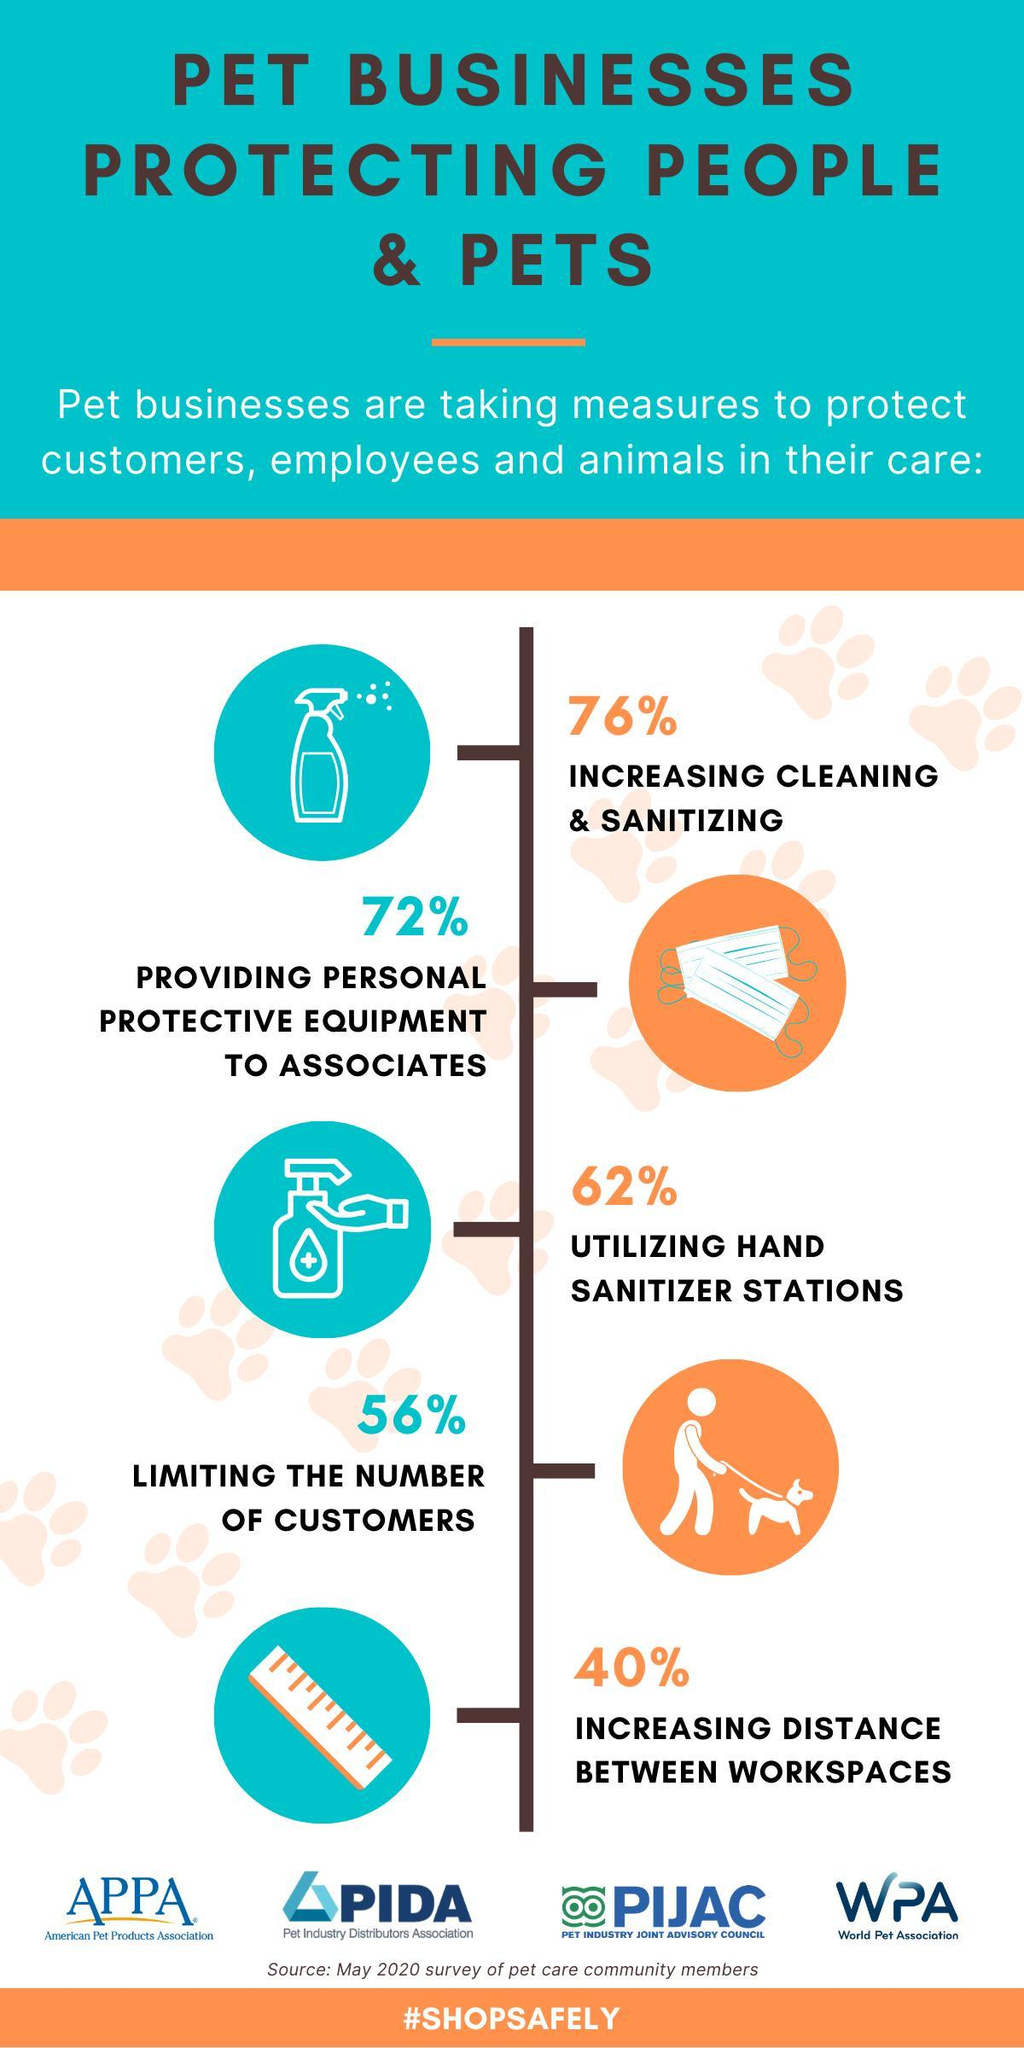How many of the businesses have increased cleaning and sanitizing?
Answer the question with a short phrase. 76% How many of the pet businesses provide protective equipment to customers 72% What measure has been taken by 40% of the pet businesses? Increasing distance between workspaces 